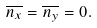<formula> <loc_0><loc_0><loc_500><loc_500>\overline { n _ { x } } = \overline { n _ { y } } = 0 .</formula> 